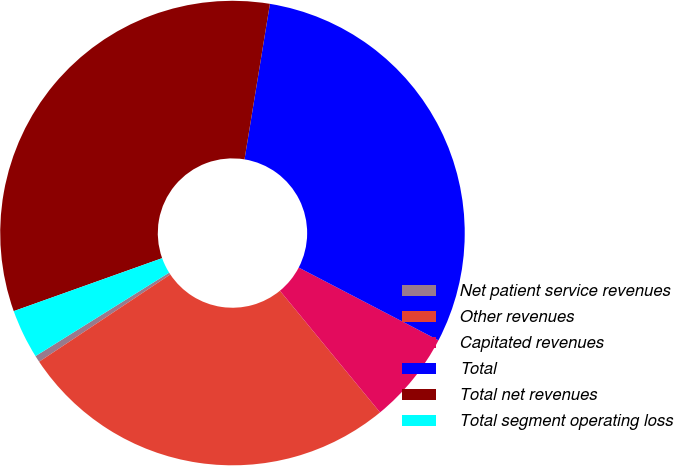Convert chart. <chart><loc_0><loc_0><loc_500><loc_500><pie_chart><fcel>Net patient service revenues<fcel>Other revenues<fcel>Capitated revenues<fcel>Total<fcel>Total net revenues<fcel>Total segment operating loss<nl><fcel>0.46%<fcel>26.61%<fcel>6.4%<fcel>30.06%<fcel>33.03%<fcel>3.43%<nl></chart> 